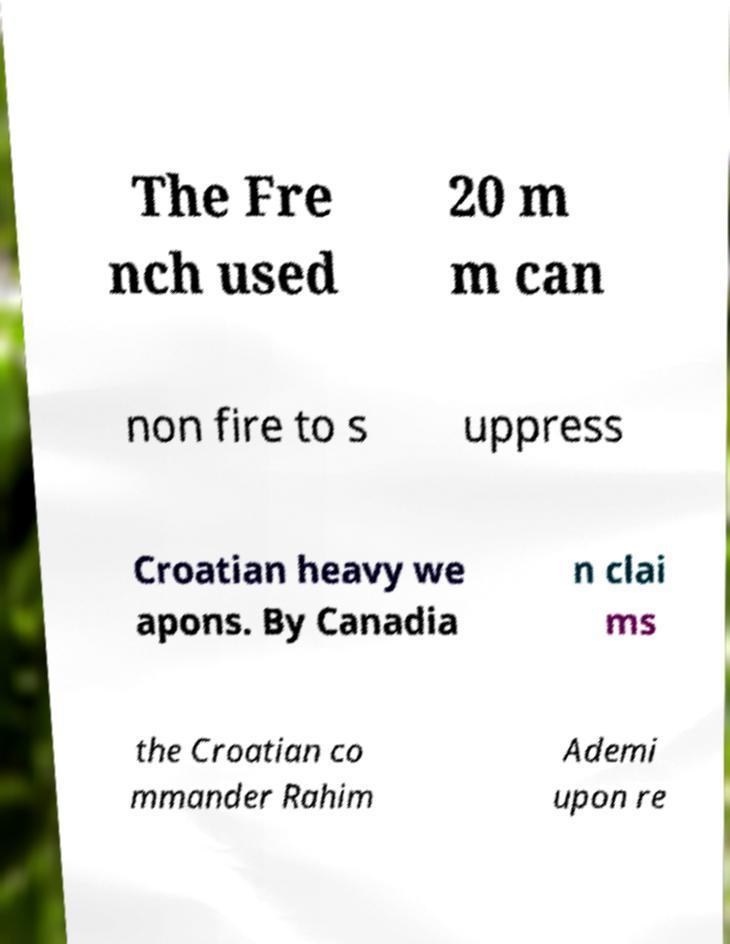What messages or text are displayed in this image? I need them in a readable, typed format. The Fre nch used 20 m m can non fire to s uppress Croatian heavy we apons. By Canadia n clai ms the Croatian co mmander Rahim Ademi upon re 